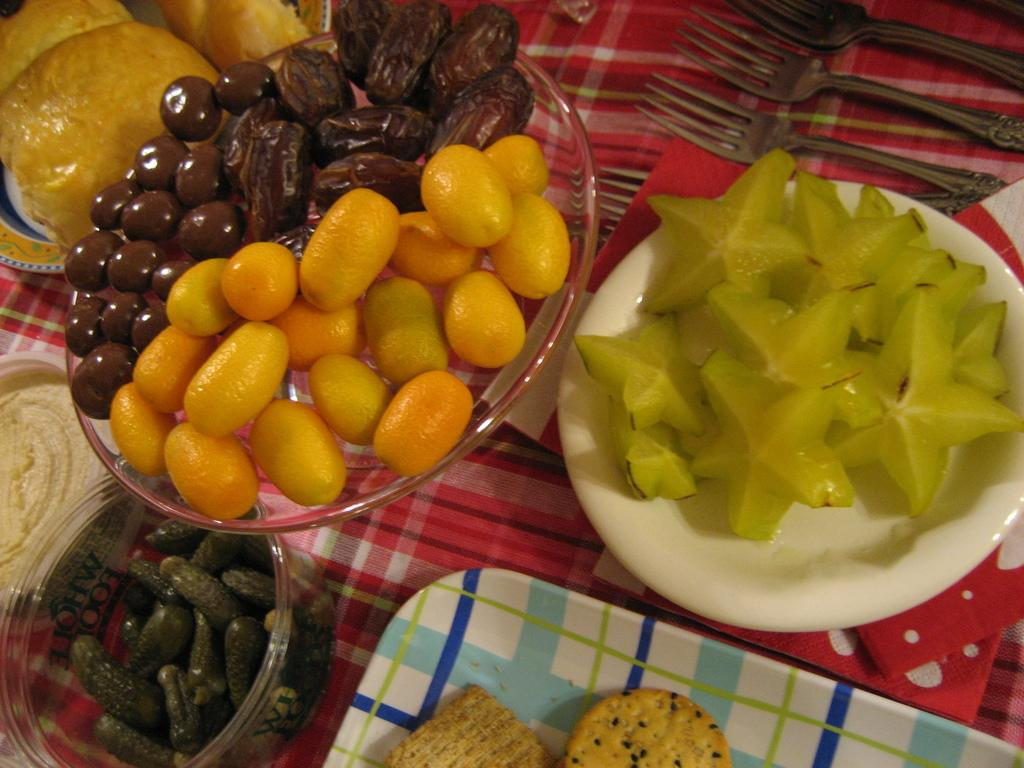What can be seen in the image related to food? There are food items arranged in plates and bowls in the image. What utensils are present on the table in the image? There are forks placed on the table in the image. What type of waste can be seen in the image? There is no waste visible in the image; it only shows food items arranged in plates and bowls, and forks placed on the table. 